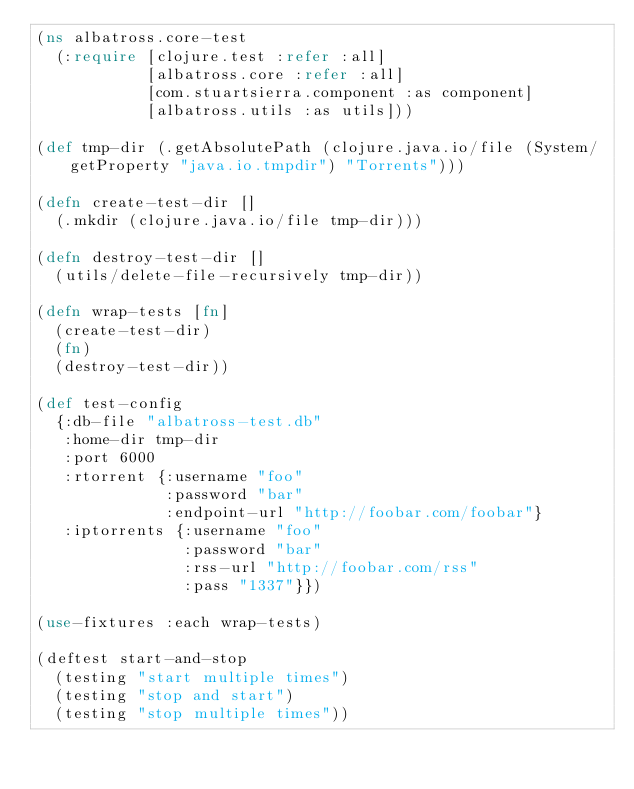Convert code to text. <code><loc_0><loc_0><loc_500><loc_500><_Clojure_>(ns albatross.core-test
  (:require [clojure.test :refer :all]
            [albatross.core :refer :all]
            [com.stuartsierra.component :as component]
            [albatross.utils :as utils]))

(def tmp-dir (.getAbsolutePath (clojure.java.io/file (System/getProperty "java.io.tmpdir") "Torrents")))

(defn create-test-dir []
  (.mkdir (clojure.java.io/file tmp-dir)))

(defn destroy-test-dir []
  (utils/delete-file-recursively tmp-dir))

(defn wrap-tests [fn]
  (create-test-dir)
  (fn)
  (destroy-test-dir))

(def test-config
  {:db-file "albatross-test.db"
   :home-dir tmp-dir
   :port 6000
   :rtorrent {:username "foo"
              :password "bar"
              :endpoint-url "http://foobar.com/foobar"}
   :iptorrents {:username "foo"
                :password "bar"
                :rss-url "http://foobar.com/rss"
                :pass "1337"}})

(use-fixtures :each wrap-tests)

(deftest start-and-stop
  (testing "start multiple times")
  (testing "stop and start")
  (testing "stop multiple times"))
</code> 